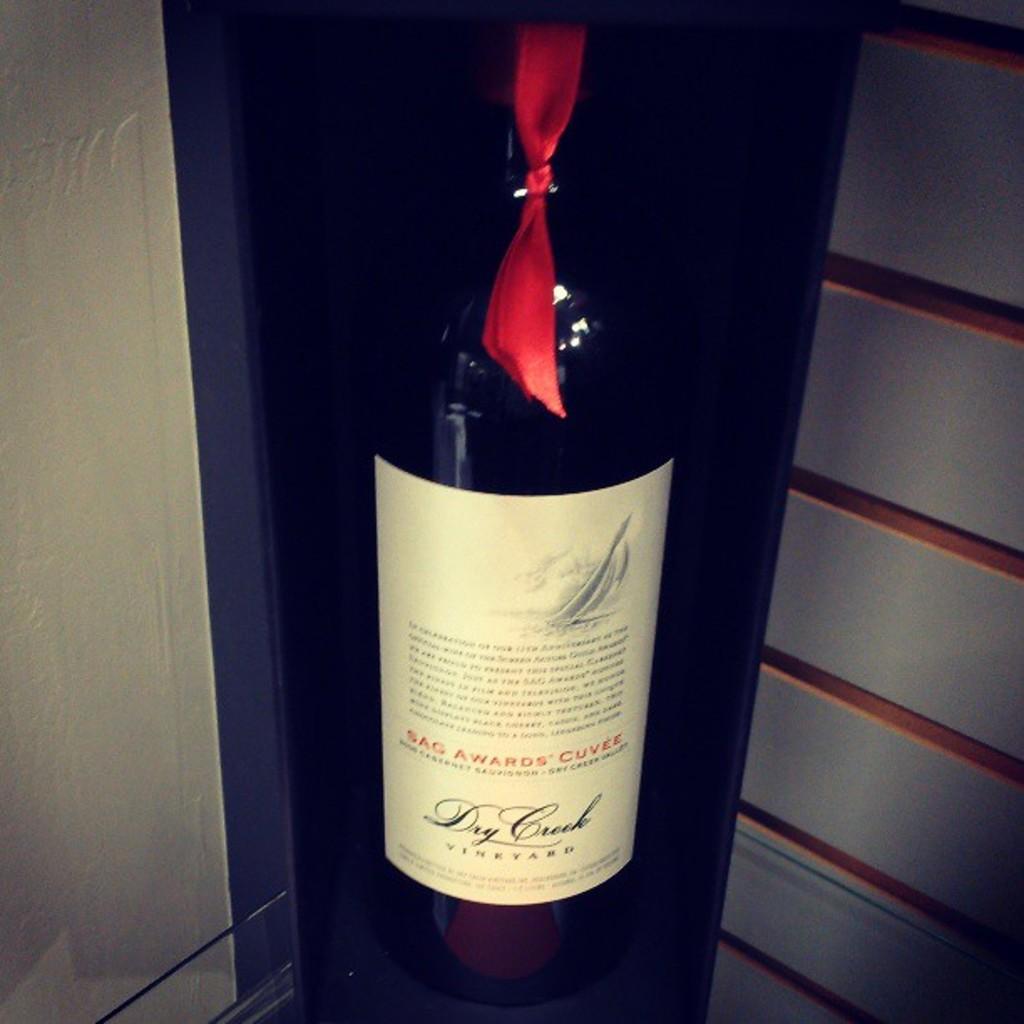What is in the bottle?
Make the answer very short. Wine. What is the name of the bottle?
Your answer should be very brief. Dry creek. 